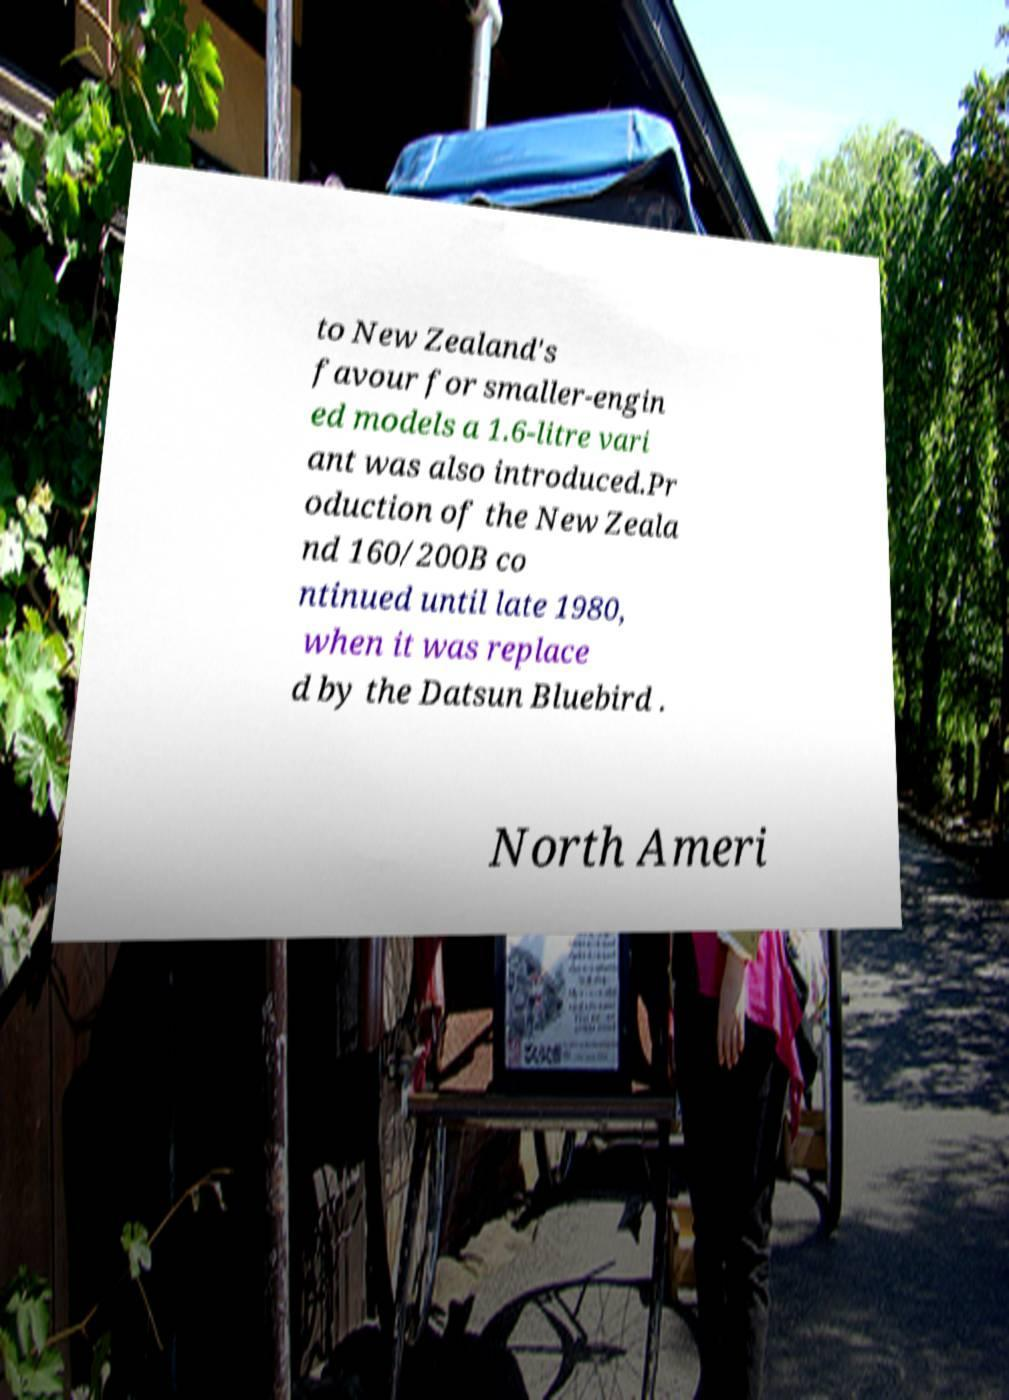Please identify and transcribe the text found in this image. to New Zealand's favour for smaller-engin ed models a 1.6-litre vari ant was also introduced.Pr oduction of the New Zeala nd 160/200B co ntinued until late 1980, when it was replace d by the Datsun Bluebird . North Ameri 